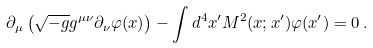<formula> <loc_0><loc_0><loc_500><loc_500>\partial _ { \mu } \left ( \sqrt { - g } g ^ { \mu \nu } \partial _ { \nu } \varphi ( x ) \right ) - \int d ^ { 4 } x ^ { \prime } M ^ { 2 } ( x ; x ^ { \prime } ) \varphi ( x ^ { \prime } ) = 0 \, .</formula> 